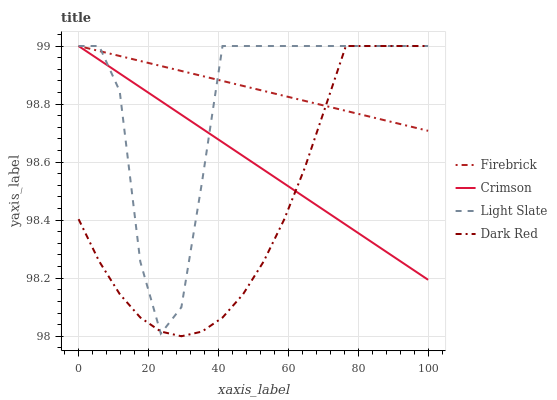Does Dark Red have the minimum area under the curve?
Answer yes or no. Yes. Does Firebrick have the maximum area under the curve?
Answer yes or no. Yes. Does Light Slate have the minimum area under the curve?
Answer yes or no. No. Does Light Slate have the maximum area under the curve?
Answer yes or no. No. Is Crimson the smoothest?
Answer yes or no. Yes. Is Light Slate the roughest?
Answer yes or no. Yes. Is Firebrick the smoothest?
Answer yes or no. No. Is Firebrick the roughest?
Answer yes or no. No. Does Dark Red have the lowest value?
Answer yes or no. Yes. Does Light Slate have the lowest value?
Answer yes or no. No. Does Dark Red have the highest value?
Answer yes or no. Yes. Does Crimson intersect Firebrick?
Answer yes or no. Yes. Is Crimson less than Firebrick?
Answer yes or no. No. Is Crimson greater than Firebrick?
Answer yes or no. No. 